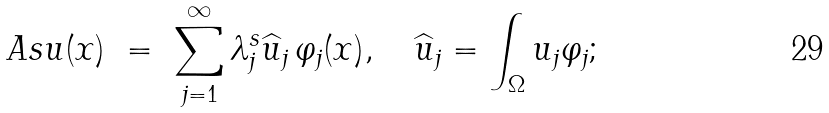<formula> <loc_0><loc_0><loc_500><loc_500>\ A s u ( x ) \ = \ \sum _ { j = 1 } ^ { \infty } \lambda _ { j } ^ { s } \widehat { u } _ { j } \, \varphi _ { j } ( x ) , \quad \widehat { u } _ { j } = \int _ { \Omega } u _ { j } \varphi _ { j } ;</formula> 